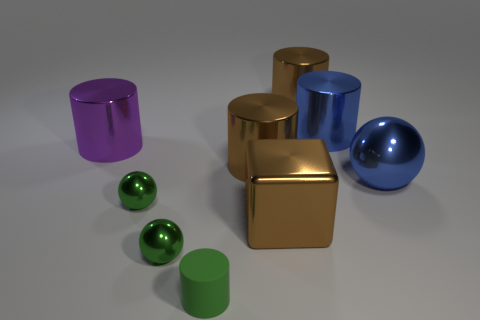Subtract all large cylinders. How many cylinders are left? 1 Subtract all purple cylinders. How many cylinders are left? 4 Subtract 1 cylinders. How many cylinders are left? 4 Subtract all red cylinders. How many yellow spheres are left? 0 Subtract all big gray matte cubes. Subtract all blue things. How many objects are left? 7 Add 8 large purple cylinders. How many large purple cylinders are left? 9 Add 2 blocks. How many blocks exist? 3 Subtract 2 brown cylinders. How many objects are left? 7 Subtract all cylinders. How many objects are left? 4 Subtract all green cubes. Subtract all cyan spheres. How many cubes are left? 1 